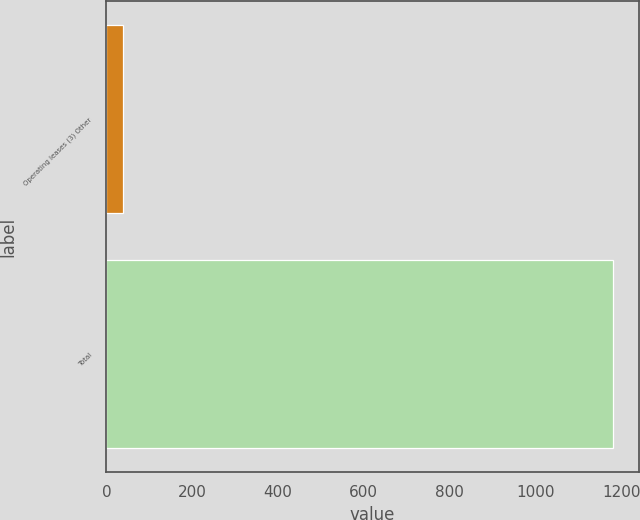Convert chart to OTSL. <chart><loc_0><loc_0><loc_500><loc_500><bar_chart><fcel>Operating leases (3) Other<fcel>Total<nl><fcel>39.3<fcel>1182.2<nl></chart> 